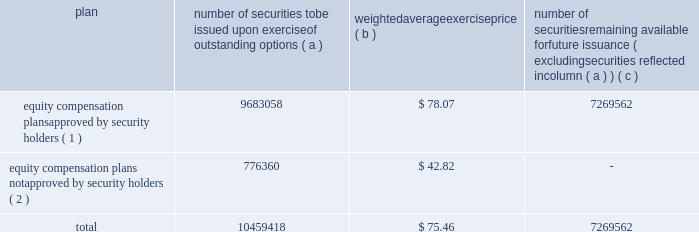Equity compensation plan information the table summarizes the equity compensation plan information as of december 31 , 2011 .
Information is included for equity compensation plans approved by the stockholders and equity compensation plans not approved by the stockholders .
Number of securities to be issued upon exercise of outstanding options weighted average exercise number of securities remaining available for future issuance ( excluding securities reflected in column ( a ) ) equity compensation plans approved by security holders ( 1 ) 9683058 $ 78.07 7269562 equity compensation plans not approved by security holders ( 2 ) 776360 $ 42.82 .
( 1 ) includes the equity ownership plan , which was approved by the shareholders on may 15 , 1998 , the 2007 equity ownership plan and the 2011 equity ownership plan .
The 2007 equity ownership plan was approved by entergy corporation shareholders on may 12 , 2006 , and 7000000 shares of entergy corporation common stock can be issued , with no more than 2000000 shares available for non-option grants .
The 2011 equity ownership plan was approved by entergy corporation shareholders on may 6 , 2011 , and 5500000 shares of entergy corporation common stock can be issued from the 2011 equity ownership plan , with no more than 2000000 shares available for incentive stock option grants .
The equity ownership plan , the 2007 equity ownership plan and the 2011 equity ownership plan ( the 201cplans 201d ) are administered by the personnel committee of the board of directors ( other than with respect to awards granted to non-employee directors , which awards are administered by the entire board of directors ) .
Eligibility under the plans is limited to the non-employee directors and to the officers and employees of an entergy system employer and any corporation 80% ( 80 % ) or more of whose stock ( based on voting power ) or value is owned , directly or indirectly , by entergy corporation .
The plans provide for the issuance of stock options , restricted shares , equity awards ( units whose value is related to the value of shares of the common stock but do not represent actual shares of common stock ) , performance awards ( performance shares or units valued by reference to shares of common stock or performance units valued by reference to financial measures or property other than common stock ) and other stock-based awards .
( 2 ) entergy has a board-approved stock-based compensation plan .
However , effective may 9 , 2003 , the board has directed that no further awards be issued under that plan .
Item 13 .
Certain relationships and related transactions and director independence for information regarding certain relationships , related transactions and director independence of entergy corporation , see the proxy statement under the headings 201ccorporate governance - director independence 201d and 201ctransactions with related persons , 201d which information is incorporated herein by reference .
Since december 31 , 2010 , none of the subsidiaries or any of their affiliates has participated in any transaction involving an amount in excess of $ 120000 in which any director or executive officer of any of the subsidiaries , any nominee for director , or any immediate family member of the foregoing had a material interest as contemplated by item 404 ( a ) of regulation s-k ( 201crelated party transactions 201d ) .
Entergy corporation 2019s board of directors has adopted written policies and procedures for the review , approval or ratification of related party transactions .
Under these policies and procedures , the corporate governance committee , or a subcommittee of the board of directors of entergy corporation composed of .
In 2011 what was the outstanding shares of the equity compensation plans approved by security holders to the shares not approved? 
Computations: (9683058 / 776360)
Answer: 12.47238. 